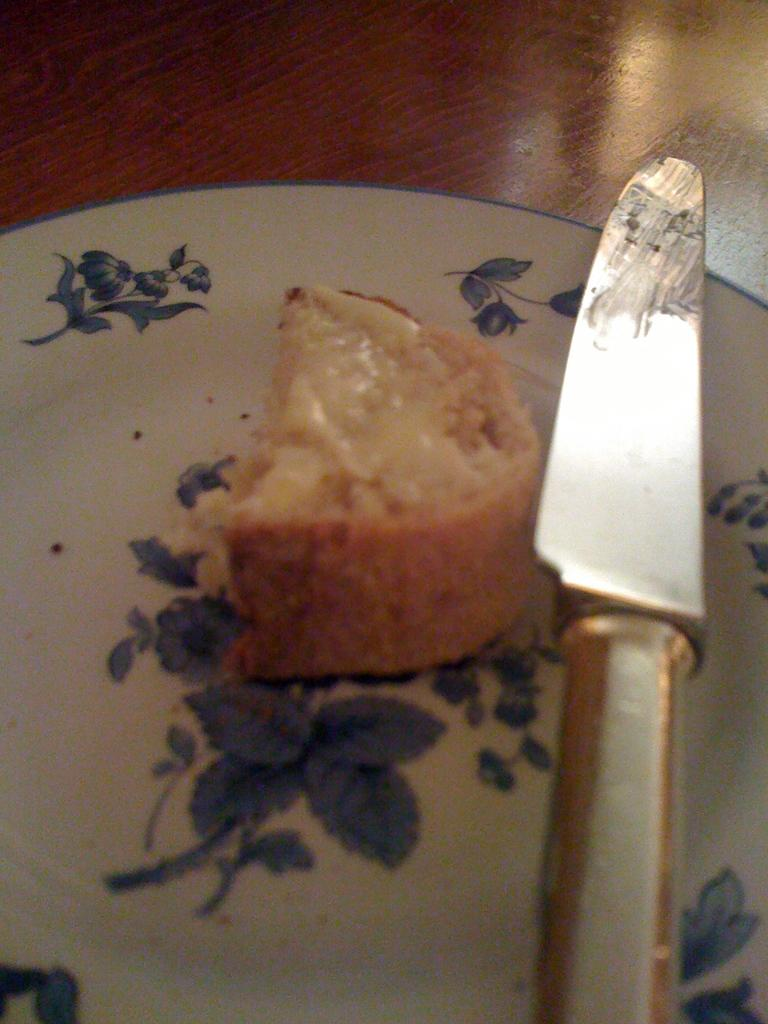What is on the plate that is visible in the image? There is a plate with cake in the image. What utensil is present in the image? There is a knife in the image. What is the color of the table in the image? The table is brown in color. How many geese are flying over the cake in the image? There are no geese present in the image; it only features a plate with cake, a knife, and a brown table. Is there an airplane visible in the image? No, there is no airplane present in the image. 